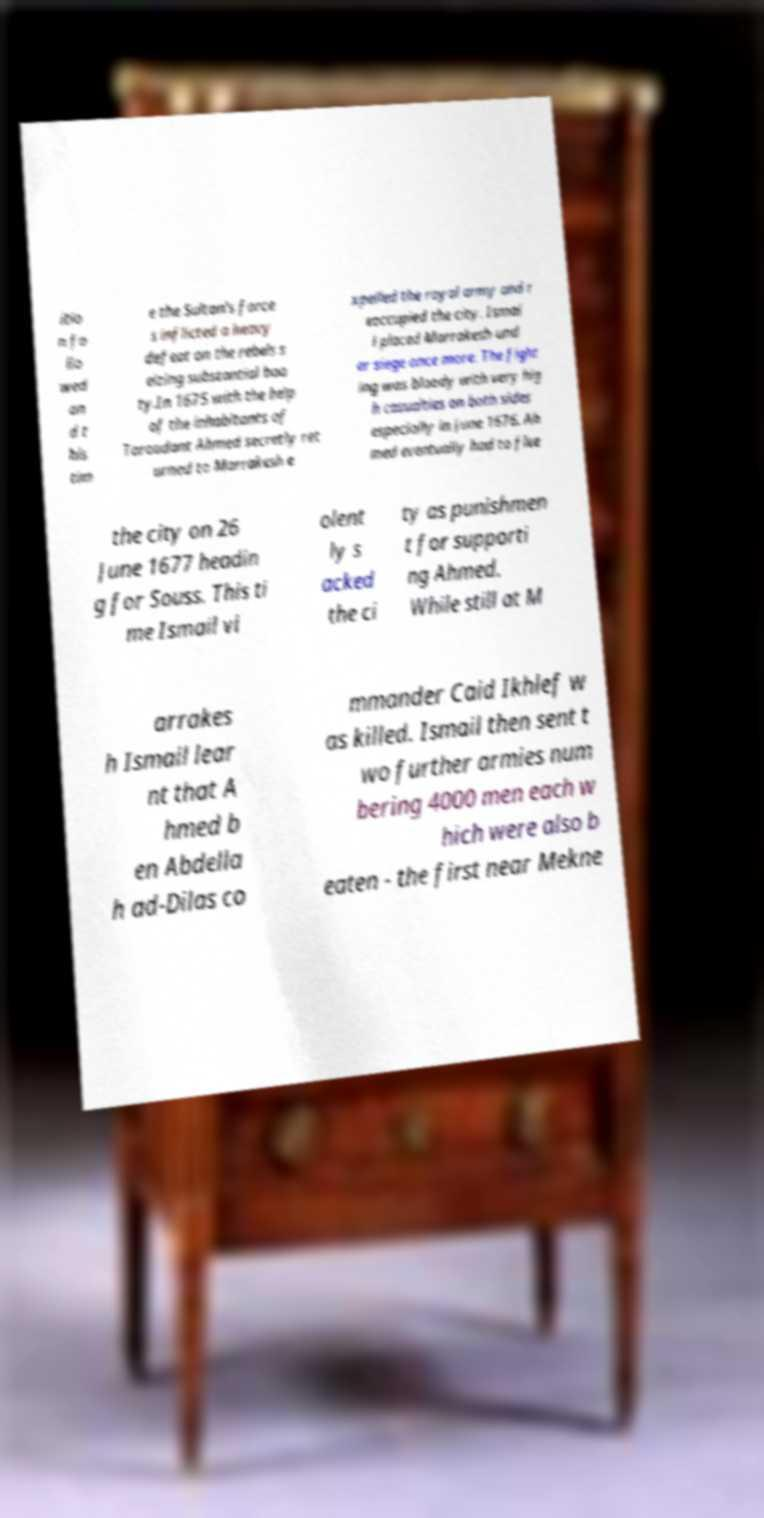Can you read and provide the text displayed in the image?This photo seems to have some interesting text. Can you extract and type it out for me? itio n fo llo wed an d t his tim e the Sultan's force s inflicted a heavy defeat on the rebels s eizing substantial boo ty.In 1675 with the help of the inhabitants of Taroudant Ahmed secretly ret urned to Marrakesh e xpelled the royal army and r eoccupied the city. Ismai l placed Marrakesh und er siege once more. The fight ing was bloody with very hig h casualties on both sides especially in June 1676. Ah med eventually had to flee the city on 26 June 1677 headin g for Souss. This ti me Ismail vi olent ly s acked the ci ty as punishmen t for supporti ng Ahmed. While still at M arrakes h Ismail lear nt that A hmed b en Abdella h ad-Dilas co mmander Caid Ikhlef w as killed. Ismail then sent t wo further armies num bering 4000 men each w hich were also b eaten - the first near Mekne 